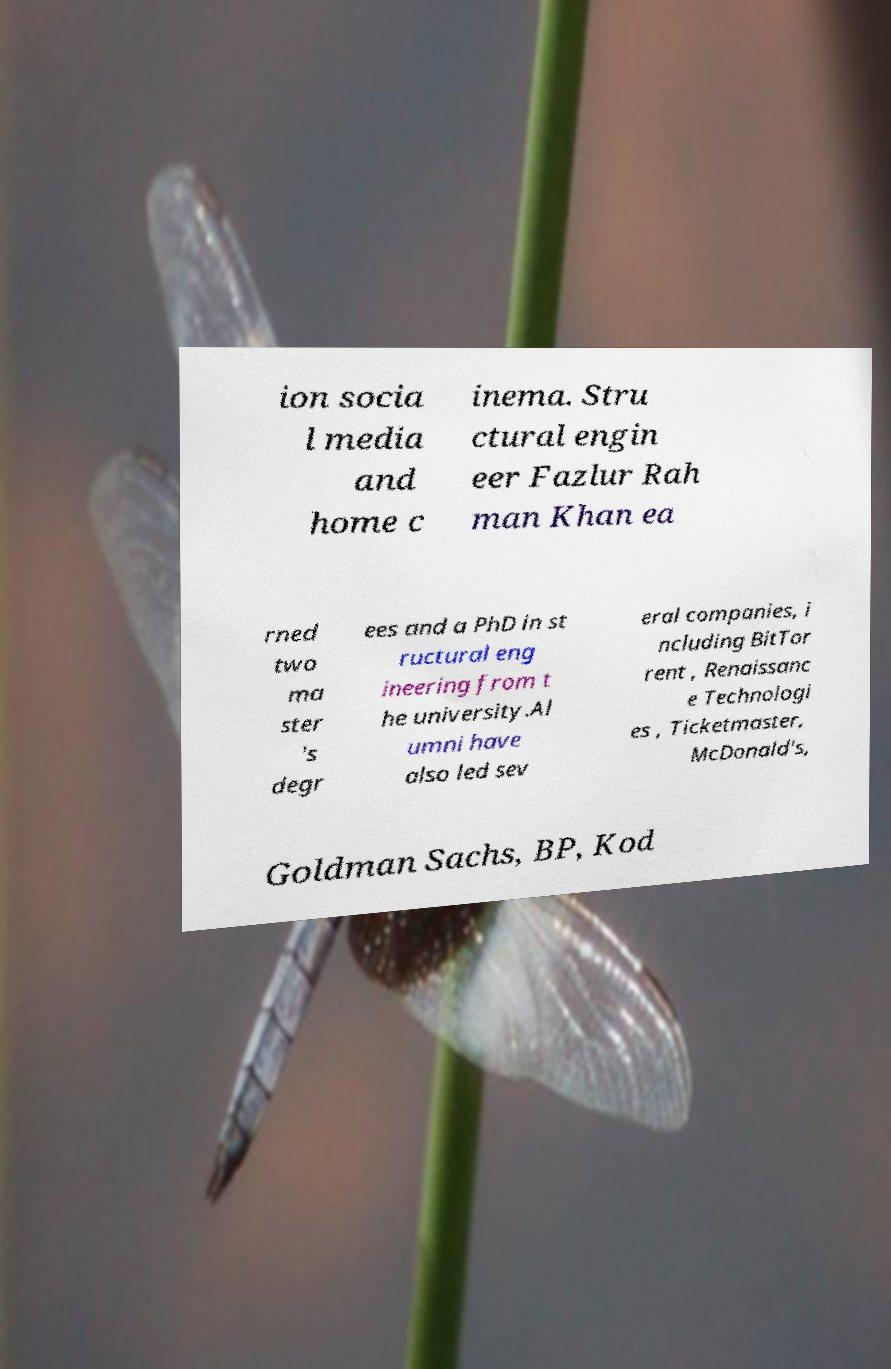Please read and relay the text visible in this image. What does it say? ion socia l media and home c inema. Stru ctural engin eer Fazlur Rah man Khan ea rned two ma ster 's degr ees and a PhD in st ructural eng ineering from t he university.Al umni have also led sev eral companies, i ncluding BitTor rent , Renaissanc e Technologi es , Ticketmaster, McDonald's, Goldman Sachs, BP, Kod 